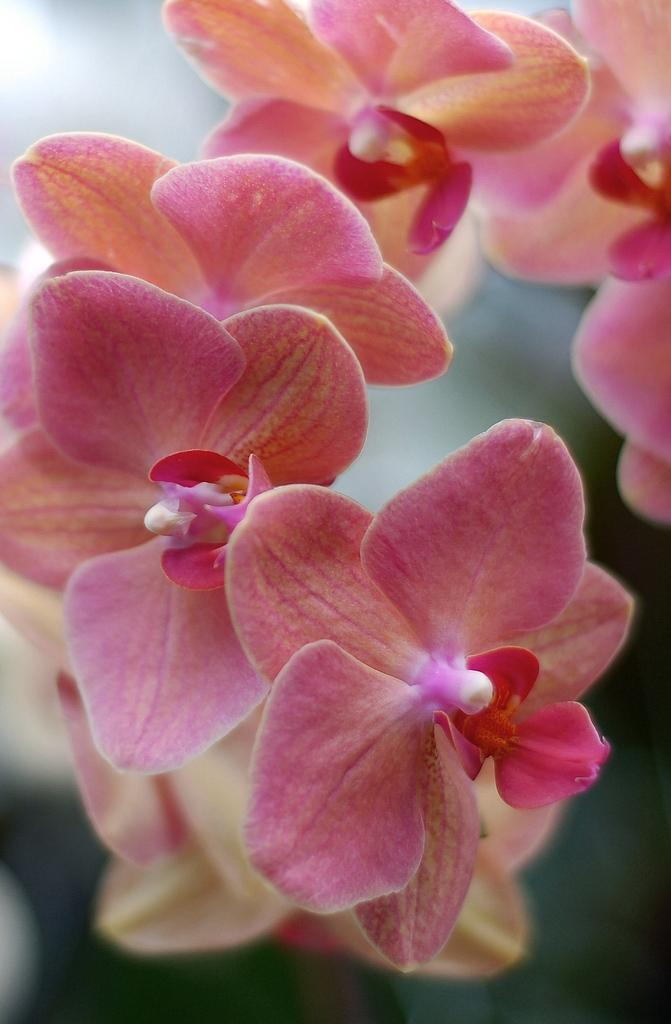What is located in the foreground of the image? There are flowers in the foreground of the image. Can you describe the background of the image? The background of the image is blurry. What type of egg can be seen in the image? There is no egg present in the image; it features flowers in the foreground and a blurry background. 